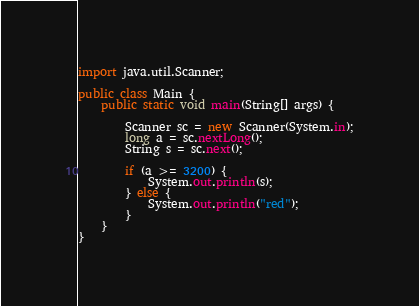Convert code to text. <code><loc_0><loc_0><loc_500><loc_500><_Java_>import java.util.Scanner;

public class Main {
    public static void main(String[] args) {

        Scanner sc = new Scanner(System.in);
        long a = sc.nextLong();
        String s = sc.next();
        
        if (a >= 3200) {
            System.out.println(s);
        } else {
            System.out.println("red");
        }
    }
}</code> 